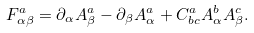Convert formula to latex. <formula><loc_0><loc_0><loc_500><loc_500>F _ { \alpha \beta } ^ { a } = \partial _ { \alpha } A _ { \beta } ^ { a } - \partial _ { \beta } A _ { \alpha } ^ { a } + C _ { b c } ^ { a } A _ { \alpha } ^ { b } A _ { \beta } ^ { c } .</formula> 